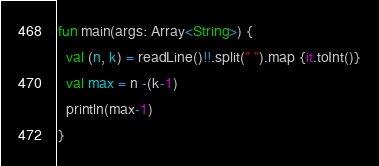Convert code to text. <code><loc_0><loc_0><loc_500><loc_500><_Kotlin_>fun main(args: Array<String>) {
  val (n, k) = readLine()!!.split(" ").map {it.toInt()}
  val max = n -(k-1)
  println(max-1)
}</code> 